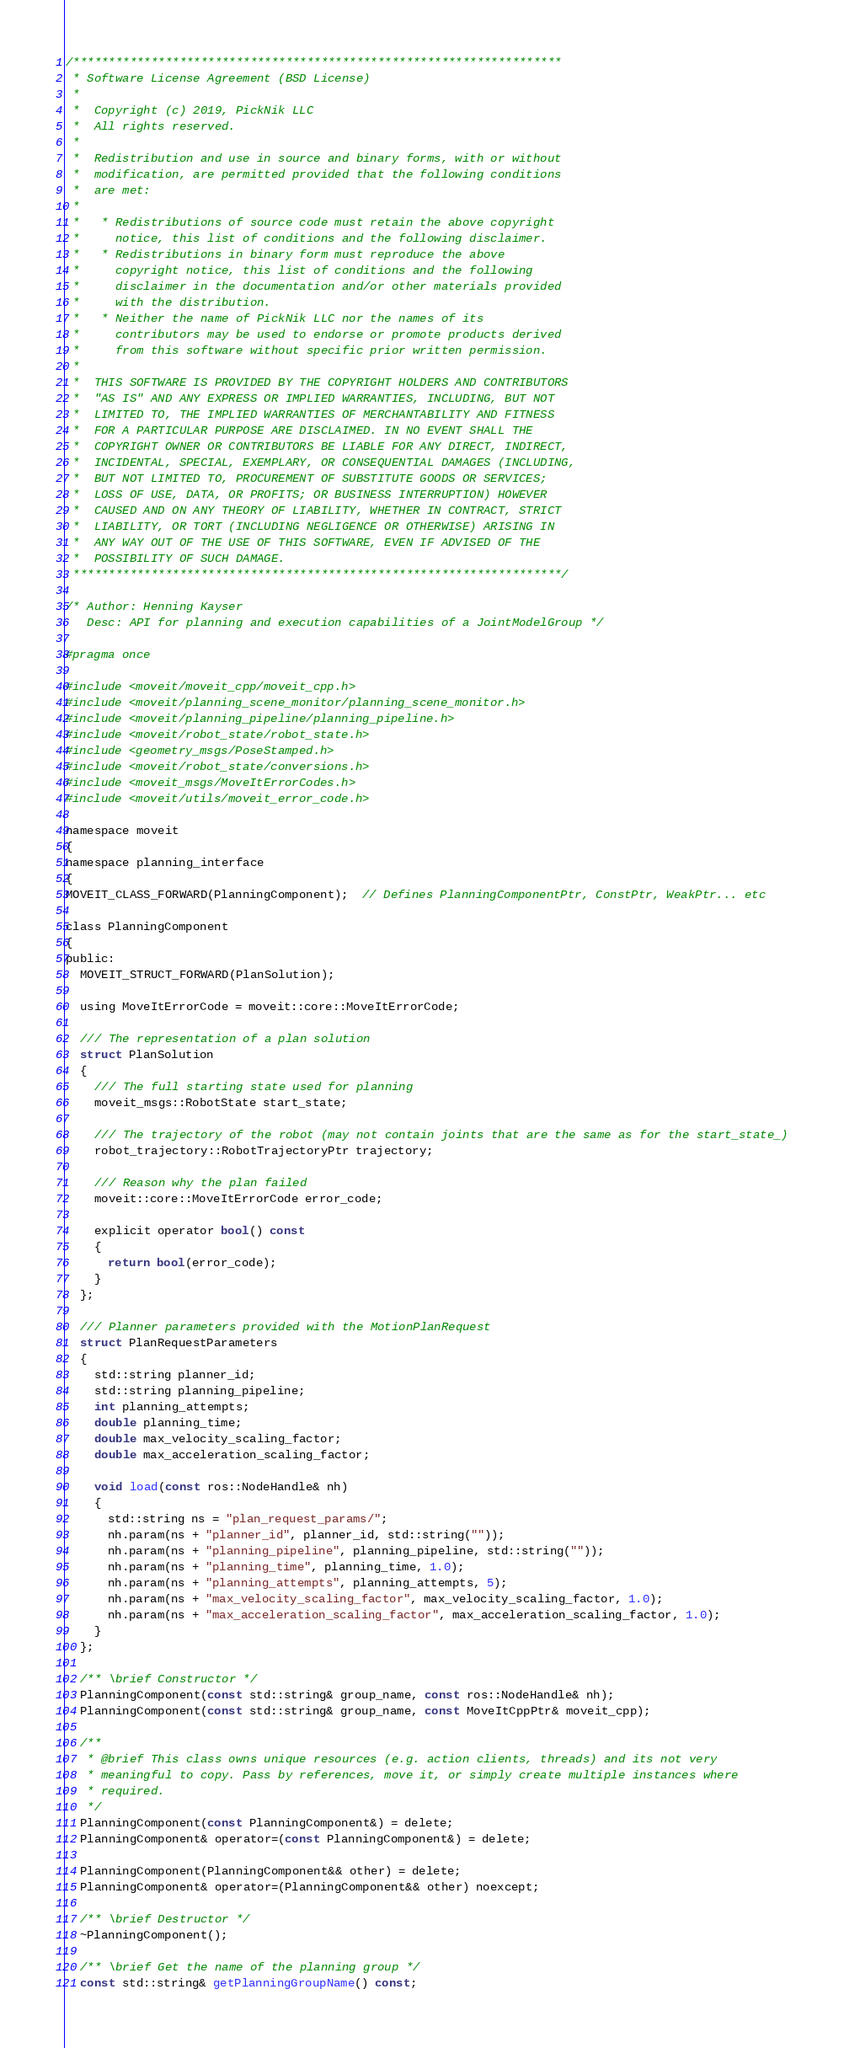<code> <loc_0><loc_0><loc_500><loc_500><_C_>/*********************************************************************
 * Software License Agreement (BSD License)
 *
 *  Copyright (c) 2019, PickNik LLC
 *  All rights reserved.
 *
 *  Redistribution and use in source and binary forms, with or without
 *  modification, are permitted provided that the following conditions
 *  are met:
 *
 *   * Redistributions of source code must retain the above copyright
 *     notice, this list of conditions and the following disclaimer.
 *   * Redistributions in binary form must reproduce the above
 *     copyright notice, this list of conditions and the following
 *     disclaimer in the documentation and/or other materials provided
 *     with the distribution.
 *   * Neither the name of PickNik LLC nor the names of its
 *     contributors may be used to endorse or promote products derived
 *     from this software without specific prior written permission.
 *
 *  THIS SOFTWARE IS PROVIDED BY THE COPYRIGHT HOLDERS AND CONTRIBUTORS
 *  "AS IS" AND ANY EXPRESS OR IMPLIED WARRANTIES, INCLUDING, BUT NOT
 *  LIMITED TO, THE IMPLIED WARRANTIES OF MERCHANTABILITY AND FITNESS
 *  FOR A PARTICULAR PURPOSE ARE DISCLAIMED. IN NO EVENT SHALL THE
 *  COPYRIGHT OWNER OR CONTRIBUTORS BE LIABLE FOR ANY DIRECT, INDIRECT,
 *  INCIDENTAL, SPECIAL, EXEMPLARY, OR CONSEQUENTIAL DAMAGES (INCLUDING,
 *  BUT NOT LIMITED TO, PROCUREMENT OF SUBSTITUTE GOODS OR SERVICES;
 *  LOSS OF USE, DATA, OR PROFITS; OR BUSINESS INTERRUPTION) HOWEVER
 *  CAUSED AND ON ANY THEORY OF LIABILITY, WHETHER IN CONTRACT, STRICT
 *  LIABILITY, OR TORT (INCLUDING NEGLIGENCE OR OTHERWISE) ARISING IN
 *  ANY WAY OUT OF THE USE OF THIS SOFTWARE, EVEN IF ADVISED OF THE
 *  POSSIBILITY OF SUCH DAMAGE.
 *********************************************************************/

/* Author: Henning Kayser
   Desc: API for planning and execution capabilities of a JointModelGroup */

#pragma once

#include <moveit/moveit_cpp/moveit_cpp.h>
#include <moveit/planning_scene_monitor/planning_scene_monitor.h>
#include <moveit/planning_pipeline/planning_pipeline.h>
#include <moveit/robot_state/robot_state.h>
#include <geometry_msgs/PoseStamped.h>
#include <moveit/robot_state/conversions.h>
#include <moveit_msgs/MoveItErrorCodes.h>
#include <moveit/utils/moveit_error_code.h>

namespace moveit
{
namespace planning_interface
{
MOVEIT_CLASS_FORWARD(PlanningComponent);  // Defines PlanningComponentPtr, ConstPtr, WeakPtr... etc

class PlanningComponent
{
public:
  MOVEIT_STRUCT_FORWARD(PlanSolution);

  using MoveItErrorCode = moveit::core::MoveItErrorCode;

  /// The representation of a plan solution
  struct PlanSolution
  {
    /// The full starting state used for planning
    moveit_msgs::RobotState start_state;

    /// The trajectory of the robot (may not contain joints that are the same as for the start_state_)
    robot_trajectory::RobotTrajectoryPtr trajectory;

    /// Reason why the plan failed
    moveit::core::MoveItErrorCode error_code;

    explicit operator bool() const
    {
      return bool(error_code);
    }
  };

  /// Planner parameters provided with the MotionPlanRequest
  struct PlanRequestParameters
  {
    std::string planner_id;
    std::string planning_pipeline;
    int planning_attempts;
    double planning_time;
    double max_velocity_scaling_factor;
    double max_acceleration_scaling_factor;

    void load(const ros::NodeHandle& nh)
    {
      std::string ns = "plan_request_params/";
      nh.param(ns + "planner_id", planner_id, std::string(""));
      nh.param(ns + "planning_pipeline", planning_pipeline, std::string(""));
      nh.param(ns + "planning_time", planning_time, 1.0);
      nh.param(ns + "planning_attempts", planning_attempts, 5);
      nh.param(ns + "max_velocity_scaling_factor", max_velocity_scaling_factor, 1.0);
      nh.param(ns + "max_acceleration_scaling_factor", max_acceleration_scaling_factor, 1.0);
    }
  };

  /** \brief Constructor */
  PlanningComponent(const std::string& group_name, const ros::NodeHandle& nh);
  PlanningComponent(const std::string& group_name, const MoveItCppPtr& moveit_cpp);

  /**
   * @brief This class owns unique resources (e.g. action clients, threads) and its not very
   * meaningful to copy. Pass by references, move it, or simply create multiple instances where
   * required.
   */
  PlanningComponent(const PlanningComponent&) = delete;
  PlanningComponent& operator=(const PlanningComponent&) = delete;

  PlanningComponent(PlanningComponent&& other) = delete;
  PlanningComponent& operator=(PlanningComponent&& other) noexcept;

  /** \brief Destructor */
  ~PlanningComponent();

  /** \brief Get the name of the planning group */
  const std::string& getPlanningGroupName() const;
</code> 